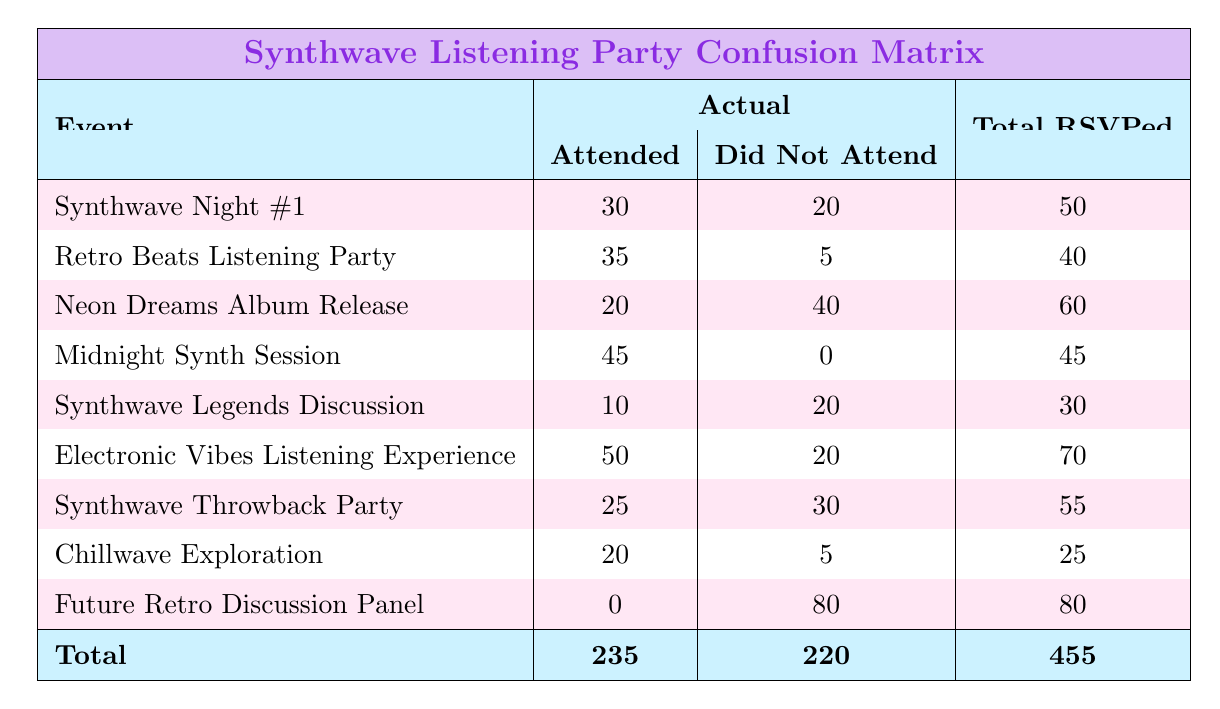What is the total number of attendees across all events? To find the total number of attendees, we need to add the number of attendees from each event. The sum is: 30 + 35 + 20 + 45 + 10 + 50 + 25 + 20 + 0 = 235.
Answer: 235 How many people did not attend the "Synthwave Legends Discussion"? The table shows that 20 people did not attend the "Synthwave Legends Discussion". This information is directly obtained from the table under the "Did Not Attend" column for that event.
Answer: 20 Which event had the highest attendance rate (attended/RSVPed)? To determine the highest attendance rate, calculate the rate for each event and compare: 
- Synthwave Night #1: 30/50 = 0.6 
- Retro Beats Listening Party: 35/40 = 0.875 
- Neon Dreams Album Release: 20/60 = 0.333 
- Midnight Synth Session: 45/45 = 1 
- Synthwave Legends Discussion: 10/30 = 0.333 
- Electronic Vibes Listening Experience: 50/70 = 0.714 
- Synthwave Throwback Party: 25/55 = 0.454 
- Chillwave Exploration: 20/25 = 0.8 
- Future Retro Discussion Panel: 0/80 = 0 
The highest rate is for "Midnight Synth Session" at 1.
Answer: Midnight Synth Session Did more people attend the "Neon Dreams Album Release" or "Synthwave Legends Discussion"? Comparing the attendees: 20 for "Neon Dreams Album Release" and 10 for "Synthwave Legends Discussion", 20 is greater than 10, so more people attended the former.
Answer: More people attended the "Neon Dreams Album Release" What is the average number of people who RSVPed for the events? To find the average, first add all the RSVPed numbers: 50 + 40 + 60 + 45 + 30 + 70 + 55 + 25 + 80 = 455. Then divide by the number of events (9): 455/9 ≈ 50.56.
Answer: 50.56 What is the total number of people who did not attend across all events? To find the total number of non-attendees, sum the "Did Not Attend" figures: 20 + 5 + 40 + 0 + 20 + 20 + 30 + 5 + 80 = 220.
Answer: 220 How many events had no attendees at all? Checking the table, only the "Future Retro Discussion Panel" shows 0 attendees, which indicates that only one event had no attendees.
Answer: 1 